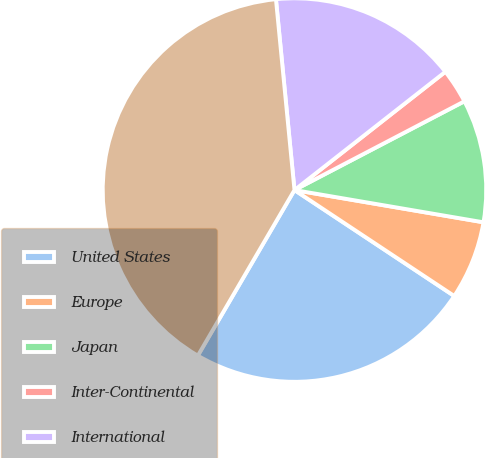Convert chart to OTSL. <chart><loc_0><loc_0><loc_500><loc_500><pie_chart><fcel>United States<fcel>Europe<fcel>Japan<fcel>Inter-Continental<fcel>International<fcel>Worldwide<nl><fcel>24.09%<fcel>6.63%<fcel>10.35%<fcel>2.92%<fcel>15.96%<fcel>40.05%<nl></chart> 